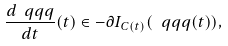Convert formula to latex. <formula><loc_0><loc_0><loc_500><loc_500>\frac { d \ q q q } { d t } ( t ) \in - \partial I _ { C ( t ) } ( \ q q q ( t ) ) ,</formula> 